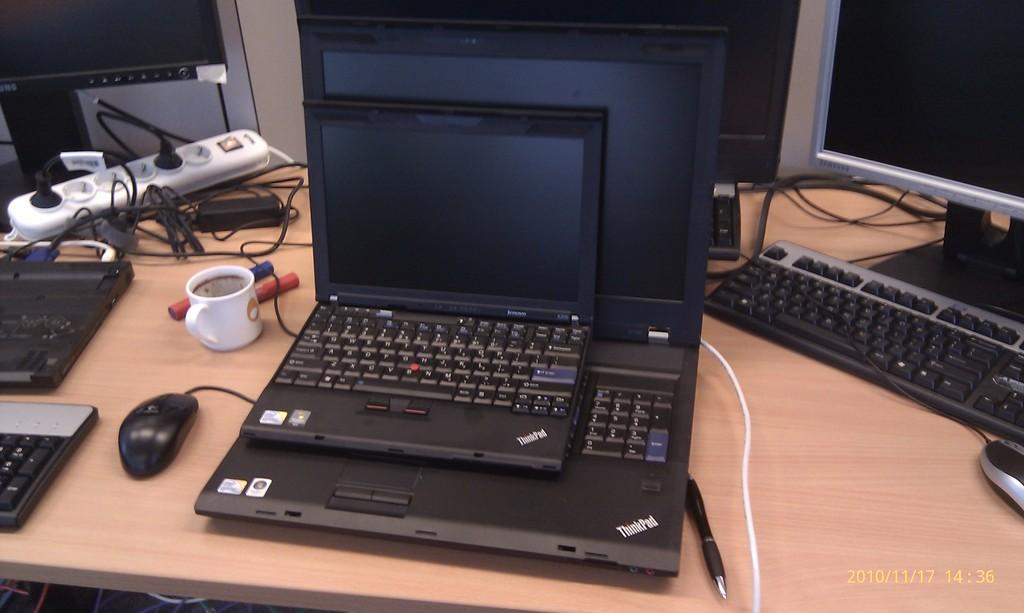<image>
Present a compact description of the photo's key features. Two Thinkpads, a smaller one on top of a larger one. 